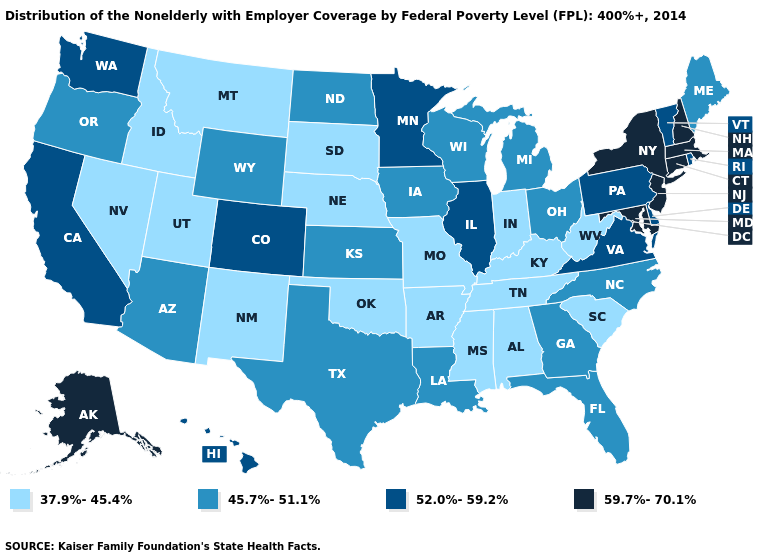Which states have the lowest value in the MidWest?
Concise answer only. Indiana, Missouri, Nebraska, South Dakota. How many symbols are there in the legend?
Concise answer only. 4. Name the states that have a value in the range 45.7%-51.1%?
Give a very brief answer. Arizona, Florida, Georgia, Iowa, Kansas, Louisiana, Maine, Michigan, North Carolina, North Dakota, Ohio, Oregon, Texas, Wisconsin, Wyoming. Name the states that have a value in the range 59.7%-70.1%?
Keep it brief. Alaska, Connecticut, Maryland, Massachusetts, New Hampshire, New Jersey, New York. What is the highest value in states that border North Carolina?
Concise answer only. 52.0%-59.2%. Name the states that have a value in the range 52.0%-59.2%?
Give a very brief answer. California, Colorado, Delaware, Hawaii, Illinois, Minnesota, Pennsylvania, Rhode Island, Vermont, Virginia, Washington. Name the states that have a value in the range 59.7%-70.1%?
Write a very short answer. Alaska, Connecticut, Maryland, Massachusetts, New Hampshire, New Jersey, New York. Name the states that have a value in the range 45.7%-51.1%?
Give a very brief answer. Arizona, Florida, Georgia, Iowa, Kansas, Louisiana, Maine, Michigan, North Carolina, North Dakota, Ohio, Oregon, Texas, Wisconsin, Wyoming. What is the value of Florida?
Give a very brief answer. 45.7%-51.1%. Which states have the lowest value in the USA?
Concise answer only. Alabama, Arkansas, Idaho, Indiana, Kentucky, Mississippi, Missouri, Montana, Nebraska, Nevada, New Mexico, Oklahoma, South Carolina, South Dakota, Tennessee, Utah, West Virginia. What is the lowest value in the South?
Quick response, please. 37.9%-45.4%. Which states have the lowest value in the West?
Concise answer only. Idaho, Montana, Nevada, New Mexico, Utah. What is the highest value in states that border South Carolina?
Answer briefly. 45.7%-51.1%. Does Maryland have the highest value in the South?
Write a very short answer. Yes. Does Illinois have the lowest value in the MidWest?
Write a very short answer. No. 